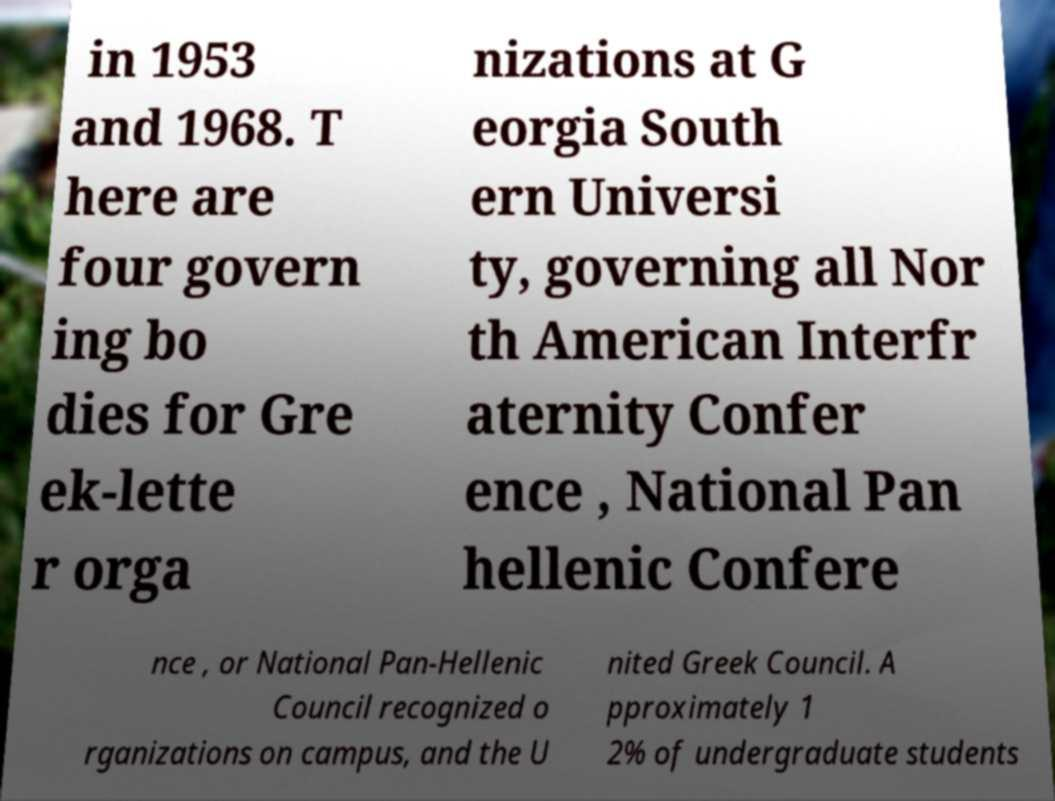For documentation purposes, I need the text within this image transcribed. Could you provide that? in 1953 and 1968. T here are four govern ing bo dies for Gre ek-lette r orga nizations at G eorgia South ern Universi ty, governing all Nor th American Interfr aternity Confer ence , National Pan hellenic Confere nce , or National Pan-Hellenic Council recognized o rganizations on campus, and the U nited Greek Council. A pproximately 1 2% of undergraduate students 